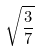Convert formula to latex. <formula><loc_0><loc_0><loc_500><loc_500>\sqrt { \frac { 3 } { 7 } }</formula> 